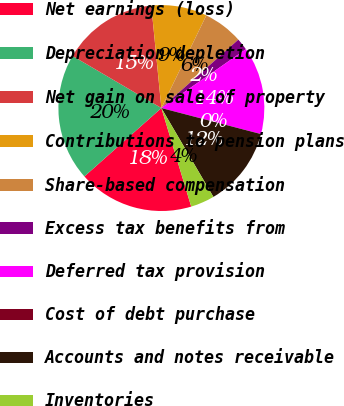Convert chart to OTSL. <chart><loc_0><loc_0><loc_500><loc_500><pie_chart><fcel>Net earnings (loss)<fcel>Depreciation depletion<fcel>Net gain on sale of property<fcel>Contributions to pension plans<fcel>Share-based compensation<fcel>Excess tax benefits from<fcel>Deferred tax provision<fcel>Cost of debt purchase<fcel>Accounts and notes receivable<fcel>Inventories<nl><fcel>18.12%<fcel>20.0%<fcel>15.0%<fcel>8.75%<fcel>6.25%<fcel>1.88%<fcel>13.75%<fcel>0.0%<fcel>12.5%<fcel>3.75%<nl></chart> 